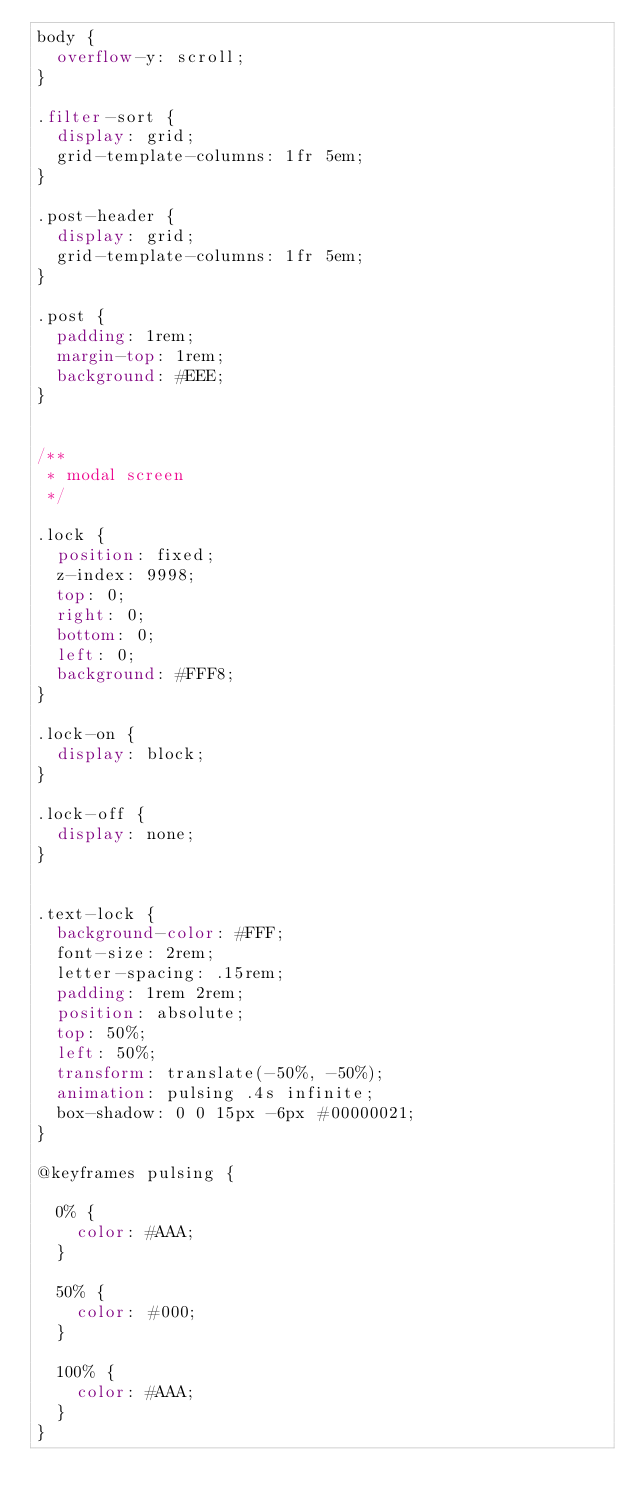<code> <loc_0><loc_0><loc_500><loc_500><_CSS_>body {
  overflow-y: scroll;
}

.filter-sort {
  display: grid;
  grid-template-columns: 1fr 5em;
}

.post-header {
  display: grid;
  grid-template-columns: 1fr 5em;
}

.post {
  padding: 1rem;
  margin-top: 1rem;
  background: #EEE;
}


/**
 * modal screen
 */

.lock {
  position: fixed;
  z-index: 9998;
  top: 0;
  right: 0;
  bottom: 0;
  left: 0;
  background: #FFF8;
}

.lock-on {
  display: block;
}

.lock-off {
  display: none;
}


.text-lock {
  background-color: #FFF;
  font-size: 2rem;
  letter-spacing: .15rem;
  padding: 1rem 2rem;
  position: absolute;
  top: 50%;
  left: 50%;
  transform: translate(-50%, -50%);
  animation: pulsing .4s infinite;
  box-shadow: 0 0 15px -6px #00000021;
}

@keyframes pulsing {

  0% {
    color: #AAA;
  }

  50% {
    color: #000;
  }

  100% {
    color: #AAA;
  }
}
</code> 